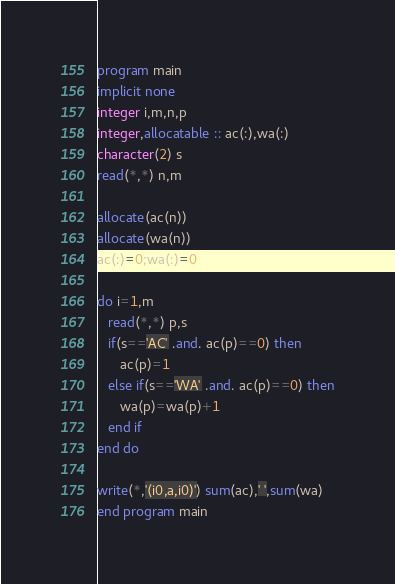<code> <loc_0><loc_0><loc_500><loc_500><_FORTRAN_>program main
implicit none
integer i,m,n,p
integer,allocatable :: ac(:),wa(:)
character(2) s
read(*,*) n,m

allocate(ac(n))
allocate(wa(n))
ac(:)=0;wa(:)=0

do i=1,m
   read(*,*) p,s
   if(s=='AC' .and. ac(p)==0) then
      ac(p)=1
   else if(s=='WA' .and. ac(p)==0) then
      wa(p)=wa(p)+1
   end if
end do
      
write(*,'(i0,a,i0)') sum(ac),' ',sum(wa)
end program main

</code> 